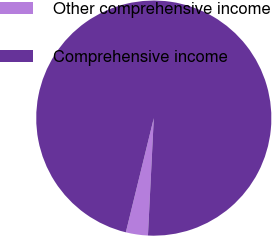Convert chart. <chart><loc_0><loc_0><loc_500><loc_500><pie_chart><fcel>Other comprehensive income<fcel>Comprehensive income<nl><fcel>3.03%<fcel>96.97%<nl></chart> 